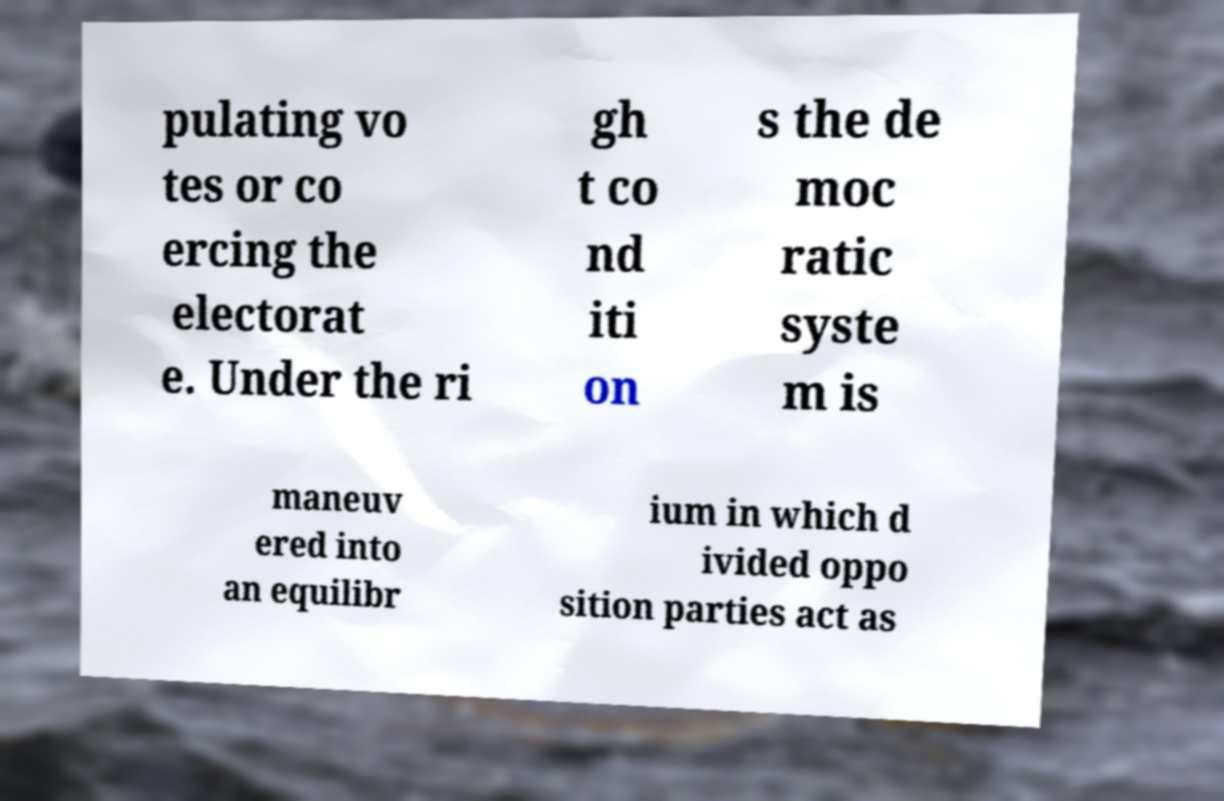Could you assist in decoding the text presented in this image and type it out clearly? pulating vo tes or co ercing the electorat e. Under the ri gh t co nd iti on s the de moc ratic syste m is maneuv ered into an equilibr ium in which d ivided oppo sition parties act as 